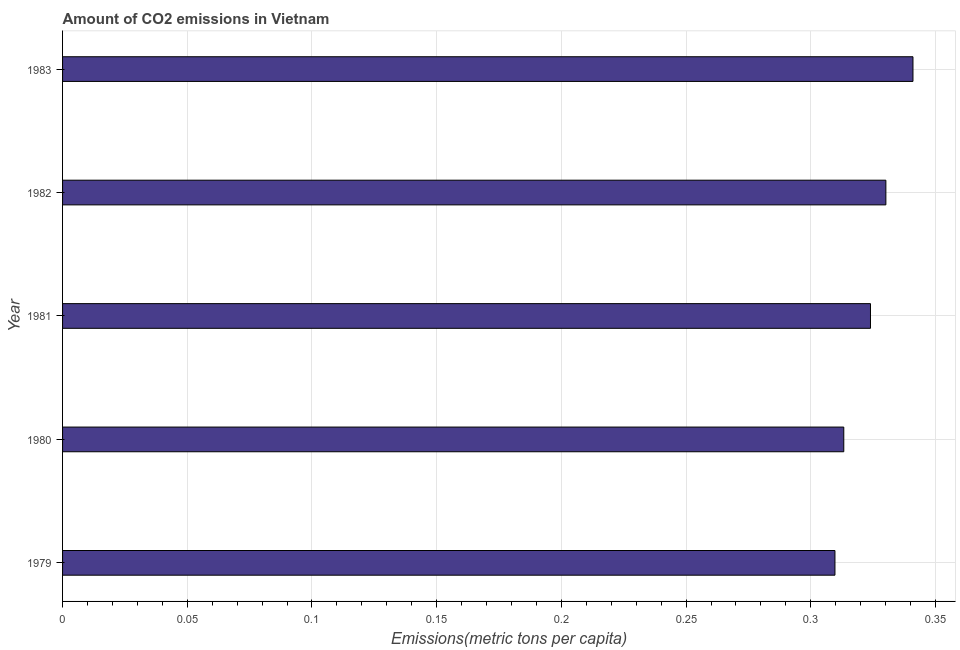Does the graph contain any zero values?
Keep it short and to the point. No. Does the graph contain grids?
Make the answer very short. Yes. What is the title of the graph?
Keep it short and to the point. Amount of CO2 emissions in Vietnam. What is the label or title of the X-axis?
Your answer should be compact. Emissions(metric tons per capita). What is the label or title of the Y-axis?
Provide a short and direct response. Year. What is the amount of co2 emissions in 1981?
Your answer should be very brief. 0.32. Across all years, what is the maximum amount of co2 emissions?
Keep it short and to the point. 0.34. Across all years, what is the minimum amount of co2 emissions?
Ensure brevity in your answer.  0.31. In which year was the amount of co2 emissions minimum?
Your answer should be very brief. 1979. What is the sum of the amount of co2 emissions?
Your answer should be compact. 1.62. What is the difference between the amount of co2 emissions in 1981 and 1983?
Provide a short and direct response. -0.02. What is the average amount of co2 emissions per year?
Provide a succinct answer. 0.32. What is the median amount of co2 emissions?
Your response must be concise. 0.32. In how many years, is the amount of co2 emissions greater than 0.18 metric tons per capita?
Offer a very short reply. 5. Is the amount of co2 emissions in 1979 less than that in 1981?
Your response must be concise. Yes. Is the difference between the amount of co2 emissions in 1980 and 1981 greater than the difference between any two years?
Your response must be concise. No. What is the difference between the highest and the second highest amount of co2 emissions?
Your answer should be compact. 0.01. Are all the bars in the graph horizontal?
Ensure brevity in your answer.  Yes. What is the Emissions(metric tons per capita) of 1979?
Your answer should be very brief. 0.31. What is the Emissions(metric tons per capita) of 1980?
Give a very brief answer. 0.31. What is the Emissions(metric tons per capita) of 1981?
Offer a terse response. 0.32. What is the Emissions(metric tons per capita) of 1982?
Offer a very short reply. 0.33. What is the Emissions(metric tons per capita) in 1983?
Your answer should be very brief. 0.34. What is the difference between the Emissions(metric tons per capita) in 1979 and 1980?
Keep it short and to the point. -0. What is the difference between the Emissions(metric tons per capita) in 1979 and 1981?
Your answer should be compact. -0.01. What is the difference between the Emissions(metric tons per capita) in 1979 and 1982?
Make the answer very short. -0.02. What is the difference between the Emissions(metric tons per capita) in 1979 and 1983?
Make the answer very short. -0.03. What is the difference between the Emissions(metric tons per capita) in 1980 and 1981?
Your answer should be very brief. -0.01. What is the difference between the Emissions(metric tons per capita) in 1980 and 1982?
Your answer should be compact. -0.02. What is the difference between the Emissions(metric tons per capita) in 1980 and 1983?
Provide a short and direct response. -0.03. What is the difference between the Emissions(metric tons per capita) in 1981 and 1982?
Ensure brevity in your answer.  -0.01. What is the difference between the Emissions(metric tons per capita) in 1981 and 1983?
Your answer should be very brief. -0.02. What is the difference between the Emissions(metric tons per capita) in 1982 and 1983?
Your response must be concise. -0.01. What is the ratio of the Emissions(metric tons per capita) in 1979 to that in 1980?
Provide a short and direct response. 0.99. What is the ratio of the Emissions(metric tons per capita) in 1979 to that in 1981?
Offer a very short reply. 0.96. What is the ratio of the Emissions(metric tons per capita) in 1979 to that in 1982?
Give a very brief answer. 0.94. What is the ratio of the Emissions(metric tons per capita) in 1979 to that in 1983?
Offer a very short reply. 0.91. What is the ratio of the Emissions(metric tons per capita) in 1980 to that in 1982?
Your response must be concise. 0.95. What is the ratio of the Emissions(metric tons per capita) in 1980 to that in 1983?
Your response must be concise. 0.92. What is the ratio of the Emissions(metric tons per capita) in 1981 to that in 1983?
Offer a very short reply. 0.95. 